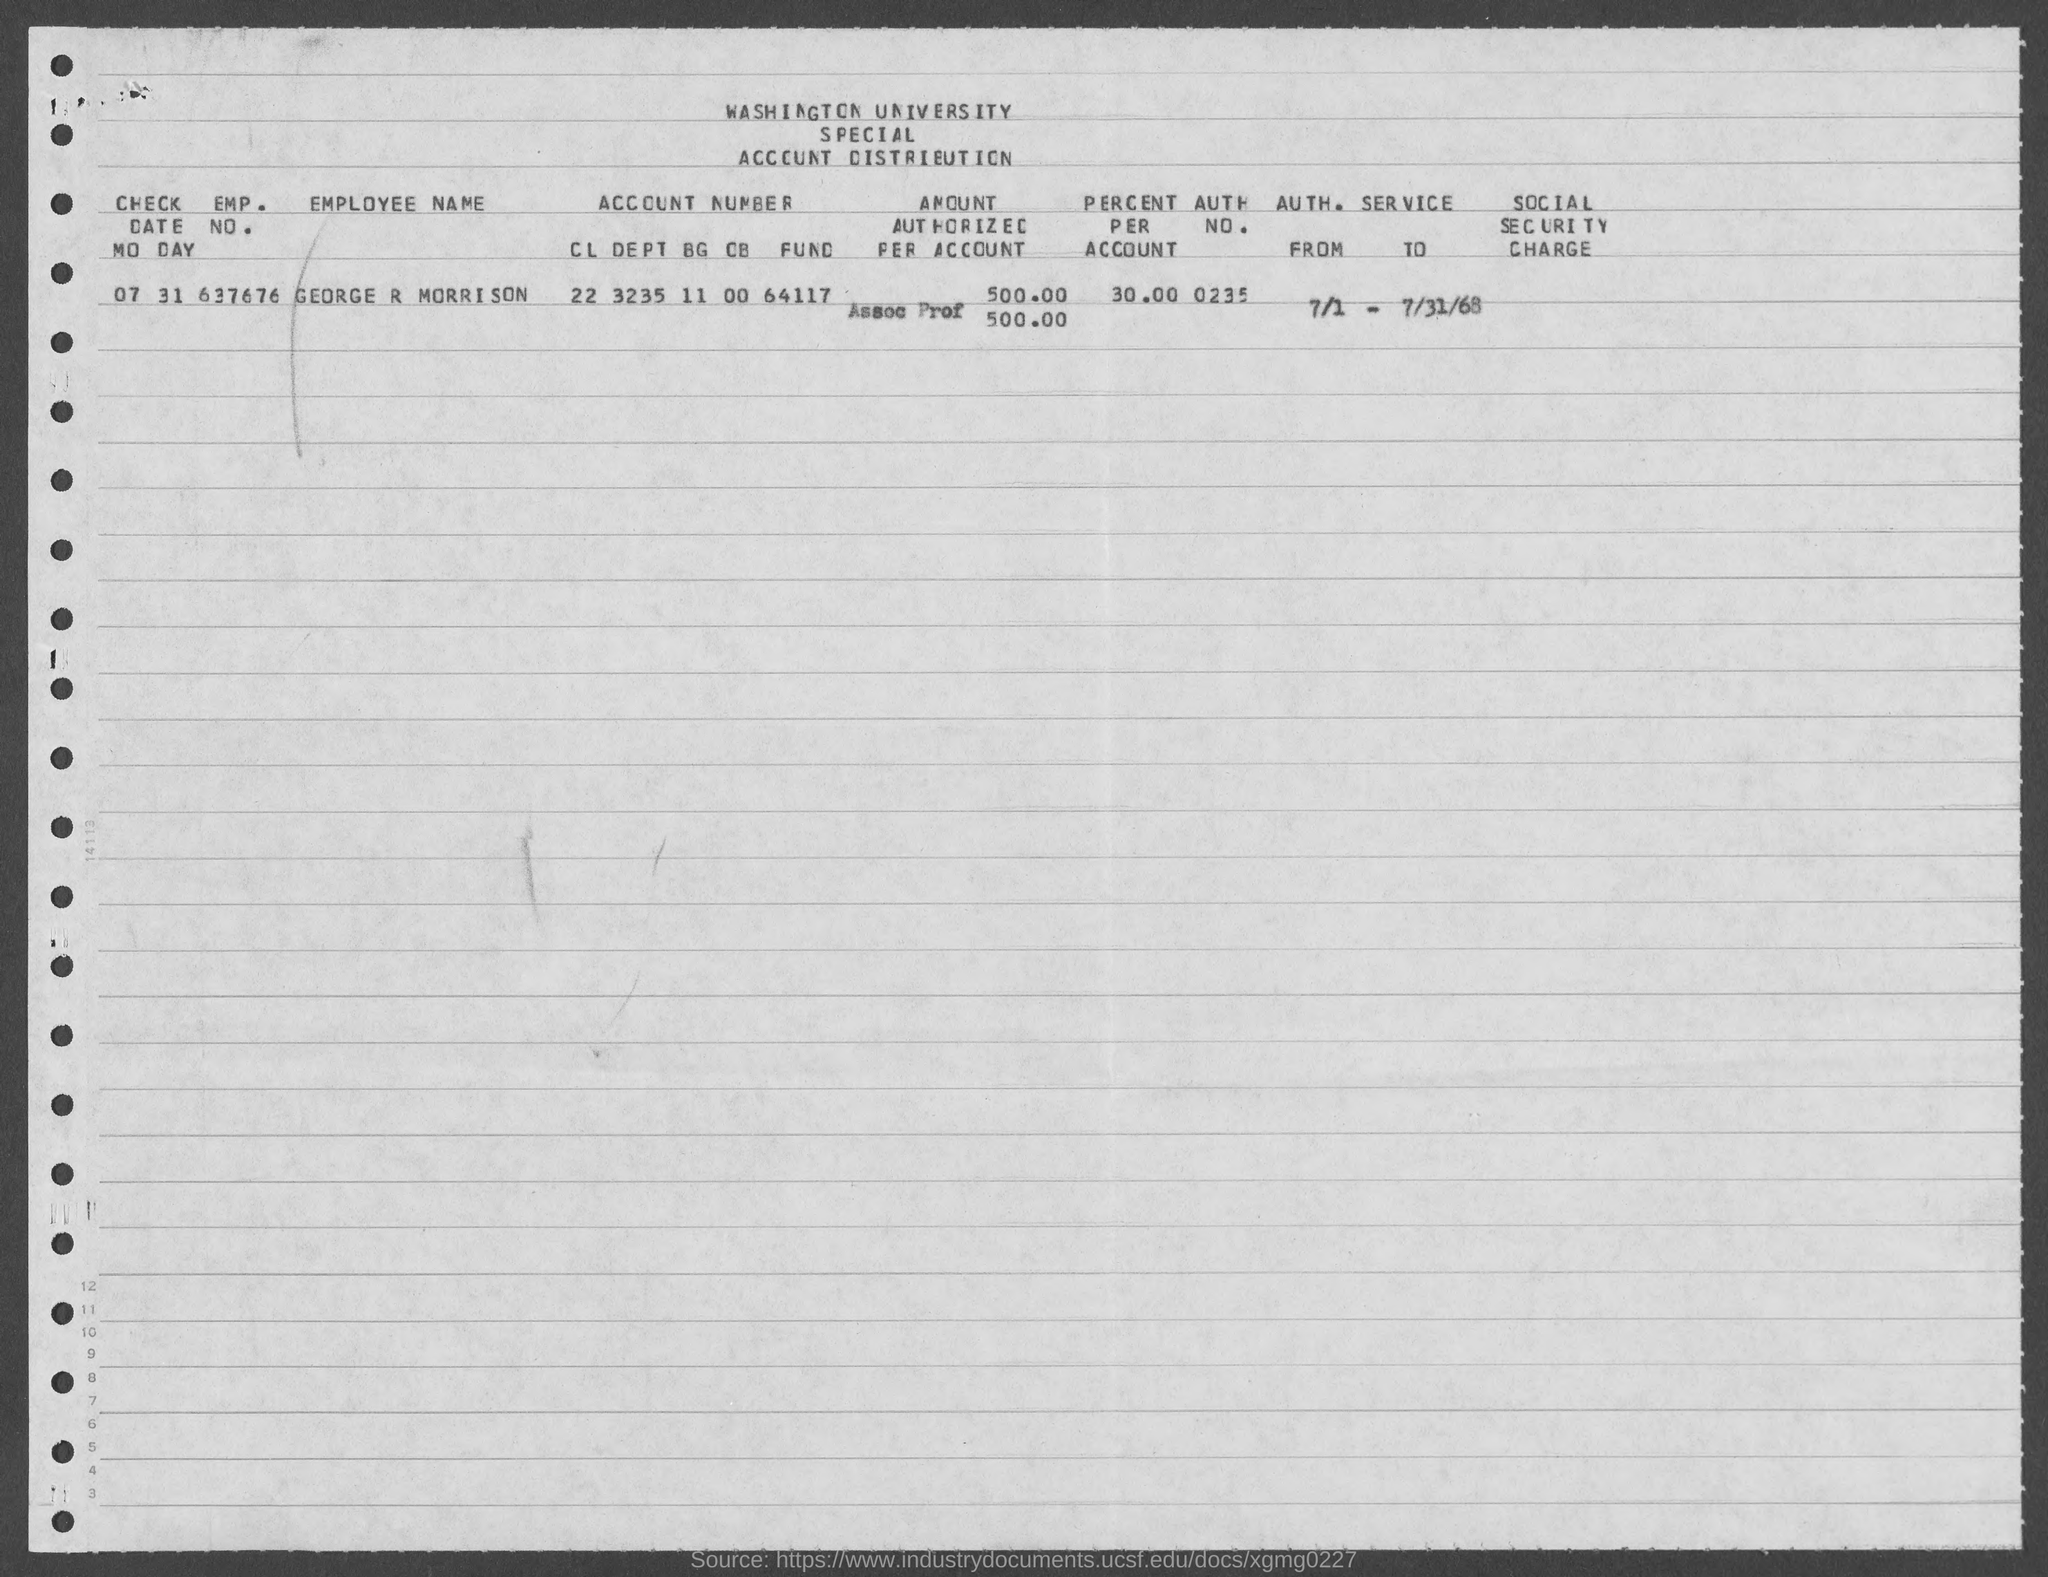Mention a couple of crucial points in this snapshot. George R Morrison holds 30% of the accounts. The emp. no. of George R Morrison is 637676. The author of the text is asking for the authorization number of someone named George R Morrison. The text appears to be a request for information, and the author is providing a partial number that appears to be a reference number or code. The text also includes the abbreviation "auth." which likely stands for "authorization. 